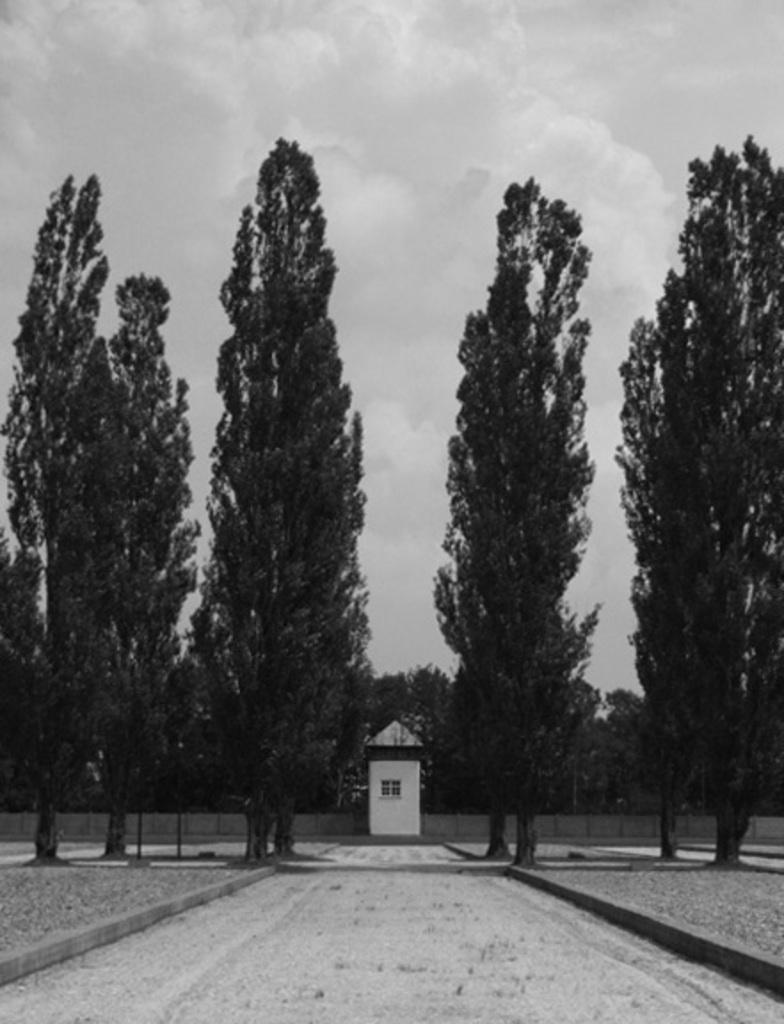What type of vegetation can be seen in the image? There are trees in the image. What type of structure is present in the image? There is a house in the image. What is visible in the background of the image? The sky is visible in the image. How many slaves are visible in the image? There are no slaves present in the image. What type of drawer can be seen in the image? There is no drawer present in the image. 